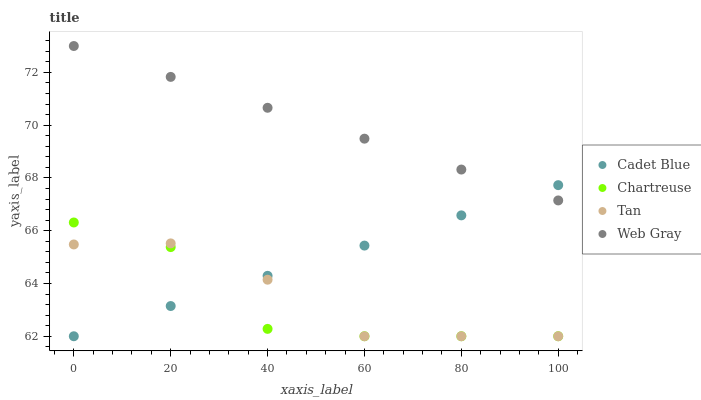Does Chartreuse have the minimum area under the curve?
Answer yes or no. Yes. Does Web Gray have the maximum area under the curve?
Answer yes or no. Yes. Does Cadet Blue have the minimum area under the curve?
Answer yes or no. No. Does Cadet Blue have the maximum area under the curve?
Answer yes or no. No. Is Web Gray the smoothest?
Answer yes or no. Yes. Is Chartreuse the roughest?
Answer yes or no. Yes. Is Cadet Blue the smoothest?
Answer yes or no. No. Is Cadet Blue the roughest?
Answer yes or no. No. Does Chartreuse have the lowest value?
Answer yes or no. Yes. Does Web Gray have the lowest value?
Answer yes or no. No. Does Web Gray have the highest value?
Answer yes or no. Yes. Does Cadet Blue have the highest value?
Answer yes or no. No. Is Chartreuse less than Web Gray?
Answer yes or no. Yes. Is Web Gray greater than Chartreuse?
Answer yes or no. Yes. Does Cadet Blue intersect Tan?
Answer yes or no. Yes. Is Cadet Blue less than Tan?
Answer yes or no. No. Is Cadet Blue greater than Tan?
Answer yes or no. No. Does Chartreuse intersect Web Gray?
Answer yes or no. No. 